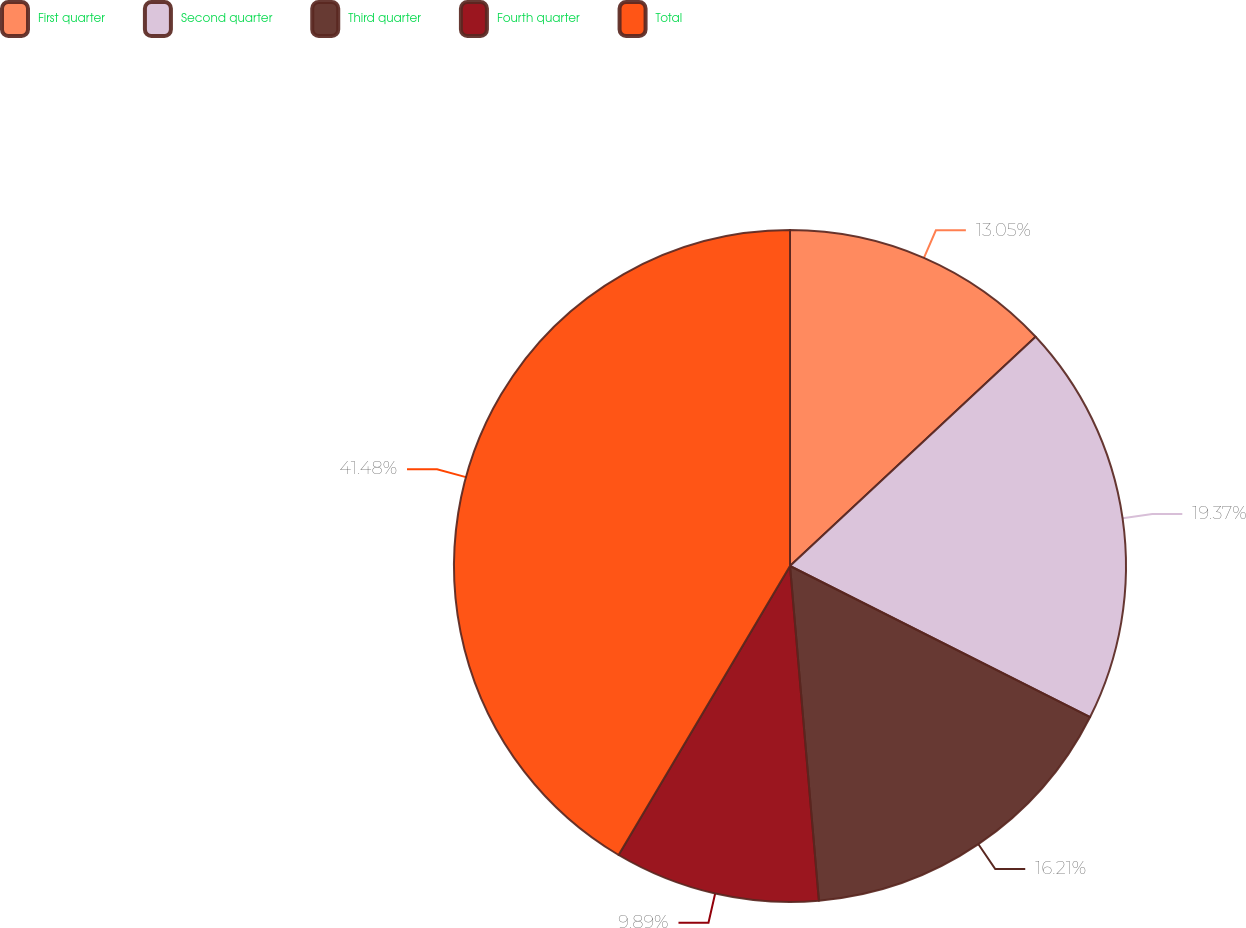<chart> <loc_0><loc_0><loc_500><loc_500><pie_chart><fcel>First quarter<fcel>Second quarter<fcel>Third quarter<fcel>Fourth quarter<fcel>Total<nl><fcel>13.05%<fcel>19.37%<fcel>16.21%<fcel>9.89%<fcel>41.48%<nl></chart> 